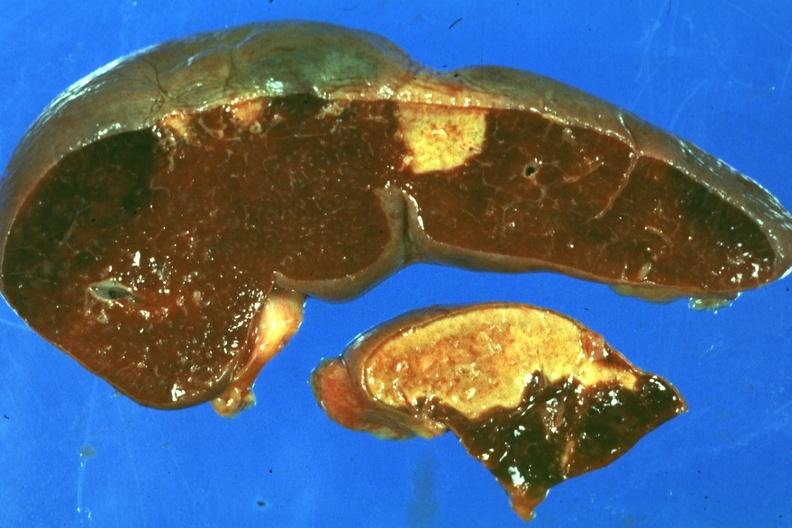does nodular tumor show typical lesion about a week or more of age?
Answer the question using a single word or phrase. No 